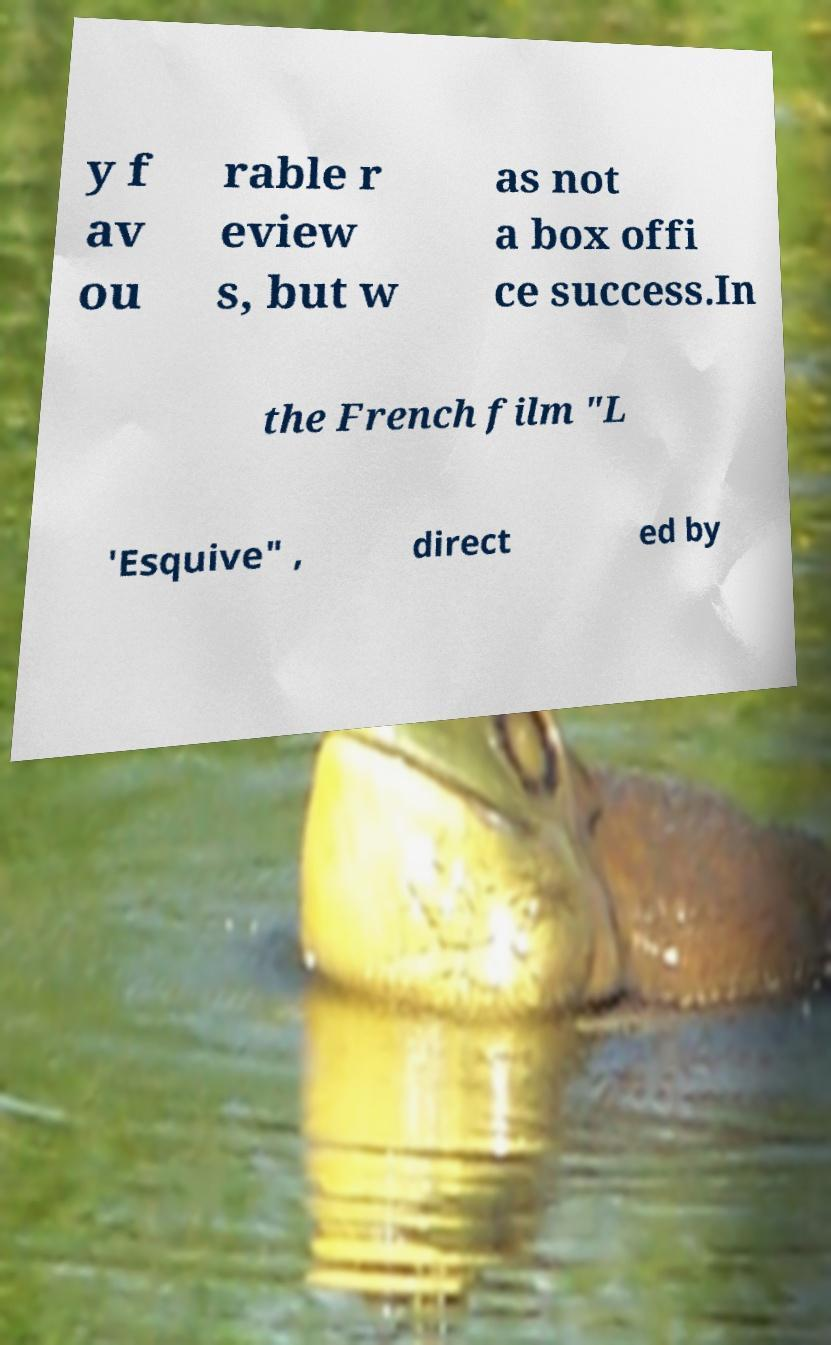What messages or text are displayed in this image? I need them in a readable, typed format. y f av ou rable r eview s, but w as not a box offi ce success.In the French film "L 'Esquive" , direct ed by 